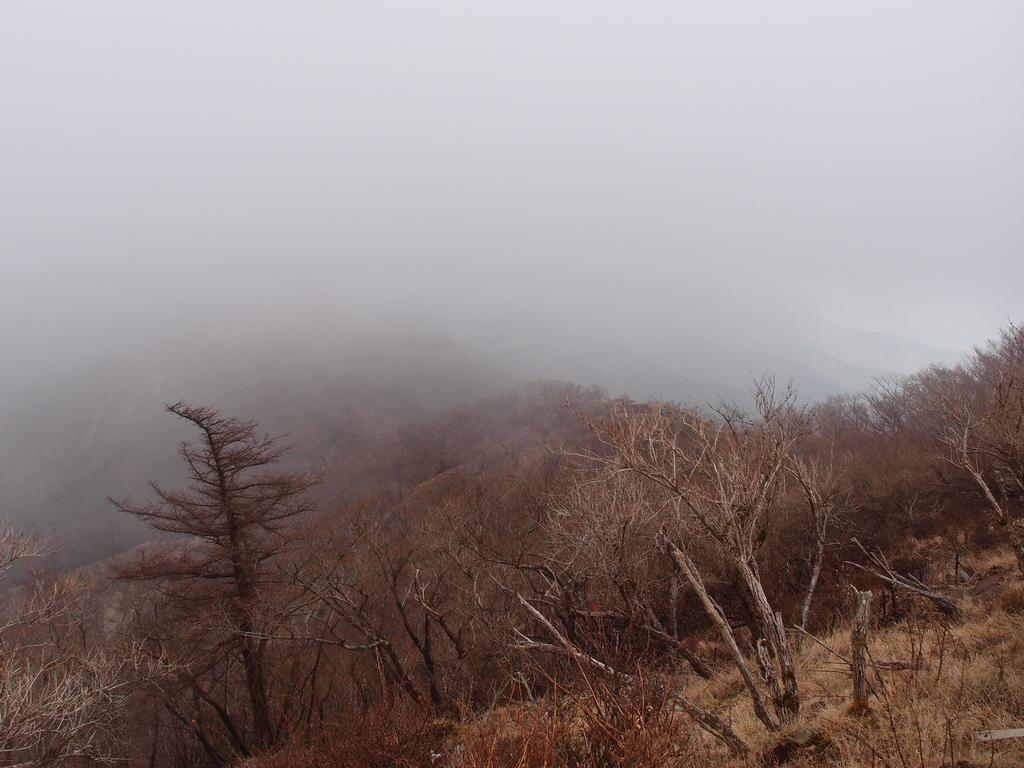What type of landscape can be seen in the image? The image features hills and many trees. Can you describe the weather or visibility in the image? There is fog visible in the image. What time is displayed on the clock in the image? There is no clock present in the image. What type of material is used to build the houses in the image? There are no houses present in the image. 